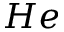Convert formula to latex. <formula><loc_0><loc_0><loc_500><loc_500>H e</formula> 